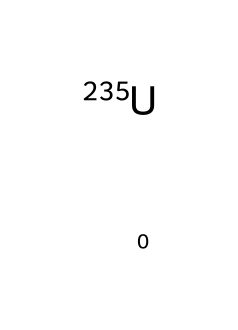What is the atomic mass number of uranium-235? The notation [235U] indicates that the element is uranium with an atomic mass number of 235. This number represents the total number of protons and neutrons in the nucleus of this isotope.
Answer: 235 How many protons does uranium-235 have? The symbol for uranium is U, and it has an atomic number of 92, which means it has 92 protons in its nucleus regardless of the isotope.
Answer: 92 What is a common use of uranium-235? Uranium-235 is primarily used as fuel in nuclear reactors for power generation, as it undergoes fission reactions that release energy.
Answer: nuclear power generation What distinguishes uranium-235 from uranium-238? The main distinction is their atomic masses; uranium-235 has an atomic mass of 235, while uranium-238 has an atomic mass of 238. This difference affects their stability and fission properties.
Answer: atomic mass Why is uranium-235 more favorable for nuclear fission than uranium-238? Uranium-235 has a higher probability of undergoing fission upon neutron absorption compared to uranium-238, making it more efficient as a fuel for nuclear reactors.
Answer: higher probability What type of radiation does uranium-235 primarily emit? Uranium-235 primarily emits alpha particles as it undergoes radioactive decay, which is characteristic of isotopes with heavy nuclei.
Answer: alpha particles 